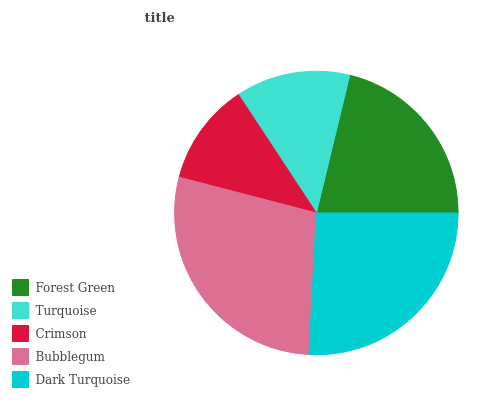Is Crimson the minimum?
Answer yes or no. Yes. Is Bubblegum the maximum?
Answer yes or no. Yes. Is Turquoise the minimum?
Answer yes or no. No. Is Turquoise the maximum?
Answer yes or no. No. Is Forest Green greater than Turquoise?
Answer yes or no. Yes. Is Turquoise less than Forest Green?
Answer yes or no. Yes. Is Turquoise greater than Forest Green?
Answer yes or no. No. Is Forest Green less than Turquoise?
Answer yes or no. No. Is Forest Green the high median?
Answer yes or no. Yes. Is Forest Green the low median?
Answer yes or no. Yes. Is Turquoise the high median?
Answer yes or no. No. Is Bubblegum the low median?
Answer yes or no. No. 